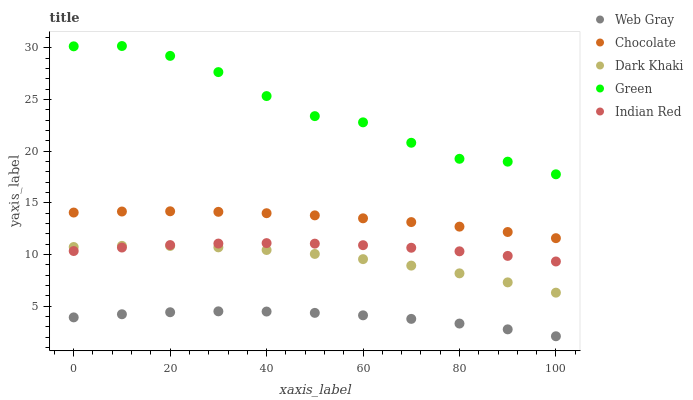Does Web Gray have the minimum area under the curve?
Answer yes or no. Yes. Does Green have the maximum area under the curve?
Answer yes or no. Yes. Does Green have the minimum area under the curve?
Answer yes or no. No. Does Web Gray have the maximum area under the curve?
Answer yes or no. No. Is Chocolate the smoothest?
Answer yes or no. Yes. Is Green the roughest?
Answer yes or no. Yes. Is Web Gray the smoothest?
Answer yes or no. No. Is Web Gray the roughest?
Answer yes or no. No. Does Web Gray have the lowest value?
Answer yes or no. Yes. Does Green have the lowest value?
Answer yes or no. No. Does Green have the highest value?
Answer yes or no. Yes. Does Web Gray have the highest value?
Answer yes or no. No. Is Chocolate less than Green?
Answer yes or no. Yes. Is Green greater than Dark Khaki?
Answer yes or no. Yes. Does Dark Khaki intersect Indian Red?
Answer yes or no. Yes. Is Dark Khaki less than Indian Red?
Answer yes or no. No. Is Dark Khaki greater than Indian Red?
Answer yes or no. No. Does Chocolate intersect Green?
Answer yes or no. No. 